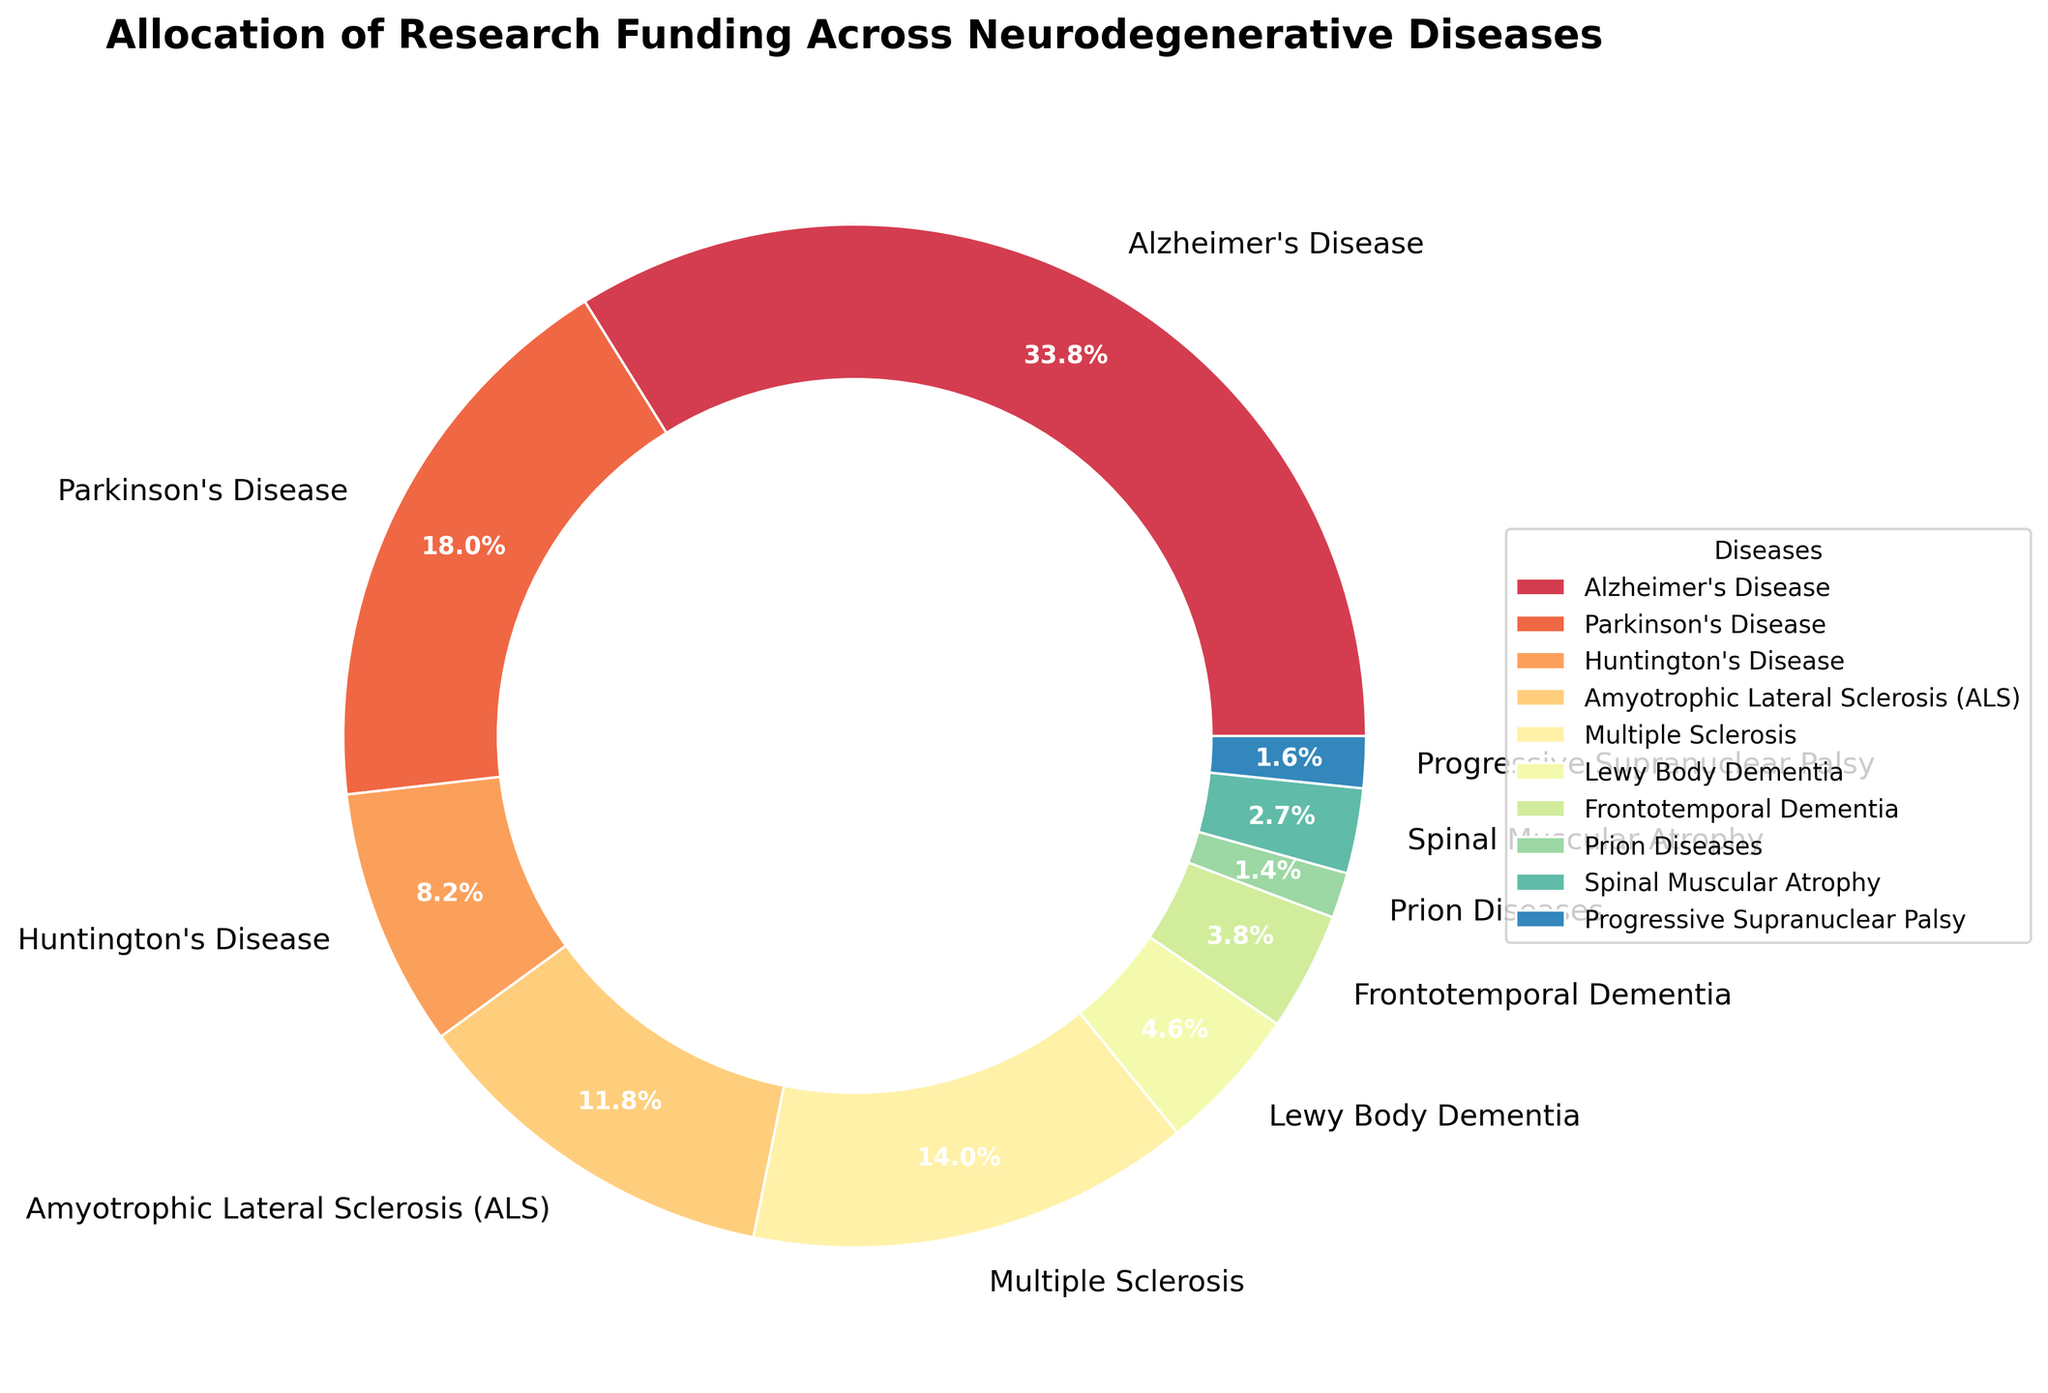Which disease receives the highest percentage of research funding? The disease with the highest percentage of research funding can be identified by looking at the largest slice of the pie chart, which is labeled "Alzheimer's Disease" with 35.2% funding.
Answer: Alzheimer's Disease How much more funding percentage does Parkinson's Disease receive compared to Lewy Body Dementia? To find the difference, subtract the funding percentage for Lewy Body Dementia from that for Parkinson's Disease: 18.7% - 4.8% = 13.9%.
Answer: 13.9% Which two diseases have the closest research funding percentages? The two diseases with the closest percentages are Progressive Supranuclear Palsy (1.7%) and Prion Diseases (1.5%). The difference in their funding is 1.7% - 1.5% = 0.2%.
Answer: Progressive Supranuclear Palsy and Prion Diseases Is the funding percentage for Multiple Sclerosis greater than the combined funding percentages for Huntington's Disease and Spinal Muscular Atrophy? The combined funding percentages for Huntington's Disease (8.5%) and Spinal Muscular Atrophy (2.8%) is 8.5% + 2.8% = 11.3%. Multiple Sclerosis receives 14.6%, which is greater than 11.3%.
Answer: Yes What proportion of the total funding is allocated to Alzheimer's Disease and Parkinson's Disease together? The combined funding percentage for Alzheimer's Disease and Parkinson's Disease is 35.2% + 18.7% = 53.9%.
Answer: 53.9% Which disease receives the least funding, and what is the percentage? The smallest slice of the pie chart represents Prion Diseases, which receives 1.5% of the funding.
Answer: Prion Diseases, 1.5% Calculate the average funding percentage for Amyotrophic Lateral Sclerosis (ALS), Multiple Sclerosis, and Frontotemporal Dementia. The average is calculated by adding the funding percentages for the three diseases and dividing by 3: (12.3% + 14.6% + 3.9%) / 3 = 10.26%.
Answer: 10.26% Which disease has a funding percentage closest to 10%? By visually inspecting the chart, the closest disease to 10% is Amyotrophic Lateral Sclerosis (ALS) with 12.3%.
Answer: Amyotrophic Lateral Sclerosis (ALS) Are there more diseases with funding percentages above or below 10%? Count the diseases above and below 10%. Above 10%: Alzheimer's Disease, Parkinson's Disease, Amyotrophic Lateral Sclerosis (ALS), and Multiple Sclerosis (4 diseases). Below 10%: Huntington's Disease, Lewy Body Dementia, Frontotemporal Dementia, Prion Diseases, Spinal Muscular Atrophy, and Progressive Supranuclear Palsy (6 diseases).
Answer: Below 10% What is the total funding percentage for diseases with less than 5% funding each? Sum the funding percentages for Lewy Body Dementia (4.8%), Frontotemporal Dementia (3.9%), Prion Diseases (1.5%), Spinal Muscular Atrophy (2.8%), and Progressive Supranuclear Palsy (1.7%): 4.8% + 3.9% + 1.5% + 2.8% + 1.7% = 14.7%.
Answer: 14.7% 